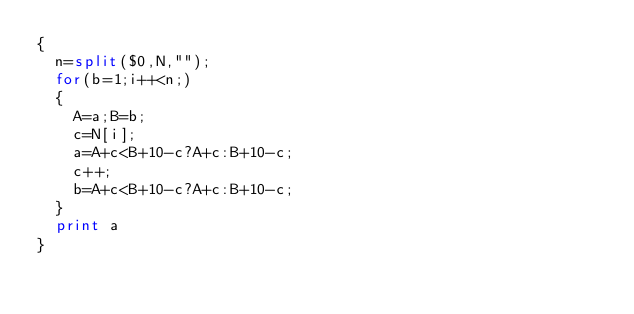<code> <loc_0><loc_0><loc_500><loc_500><_Awk_>{
	n=split($0,N,"");
	for(b=1;i++<n;)
	{
		A=a;B=b;
		c=N[i];
		a=A+c<B+10-c?A+c:B+10-c;
		c++;
		b=A+c<B+10-c?A+c:B+10-c;
	}
	print a
}
</code> 